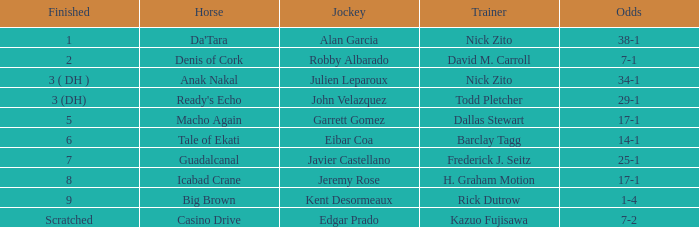Which jockey works with trainer nick zito and has 34-1 odds? Julien Leparoux. 